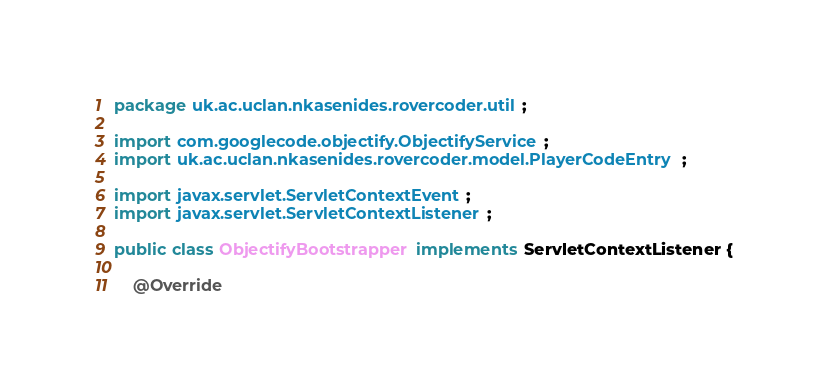Convert code to text. <code><loc_0><loc_0><loc_500><loc_500><_Java_>package uk.ac.uclan.nkasenides.rovercoder.util;

import com.googlecode.objectify.ObjectifyService;
import uk.ac.uclan.nkasenides.rovercoder.model.PlayerCodeEntry;

import javax.servlet.ServletContextEvent;
import javax.servlet.ServletContextListener;

public class ObjectifyBootstrapper implements ServletContextListener {

    @Override</code> 